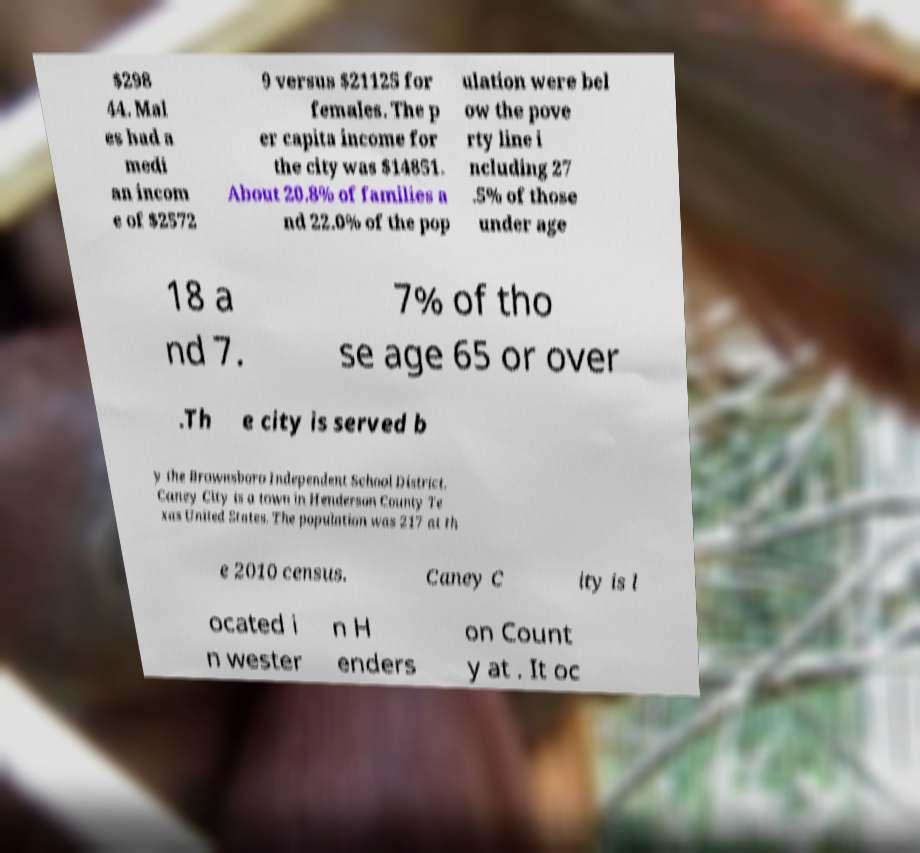There's text embedded in this image that I need extracted. Can you transcribe it verbatim? $298 44. Mal es had a medi an incom e of $2572 9 versus $21125 for females. The p er capita income for the city was $14851. About 20.8% of families a nd 22.0% of the pop ulation were bel ow the pove rty line i ncluding 27 .5% of those under age 18 a nd 7. 7% of tho se age 65 or over .Th e city is served b y the Brownsboro Independent School District. Caney City is a town in Henderson County Te xas United States. The population was 217 at th e 2010 census. Caney C ity is l ocated i n wester n H enders on Count y at . It oc 